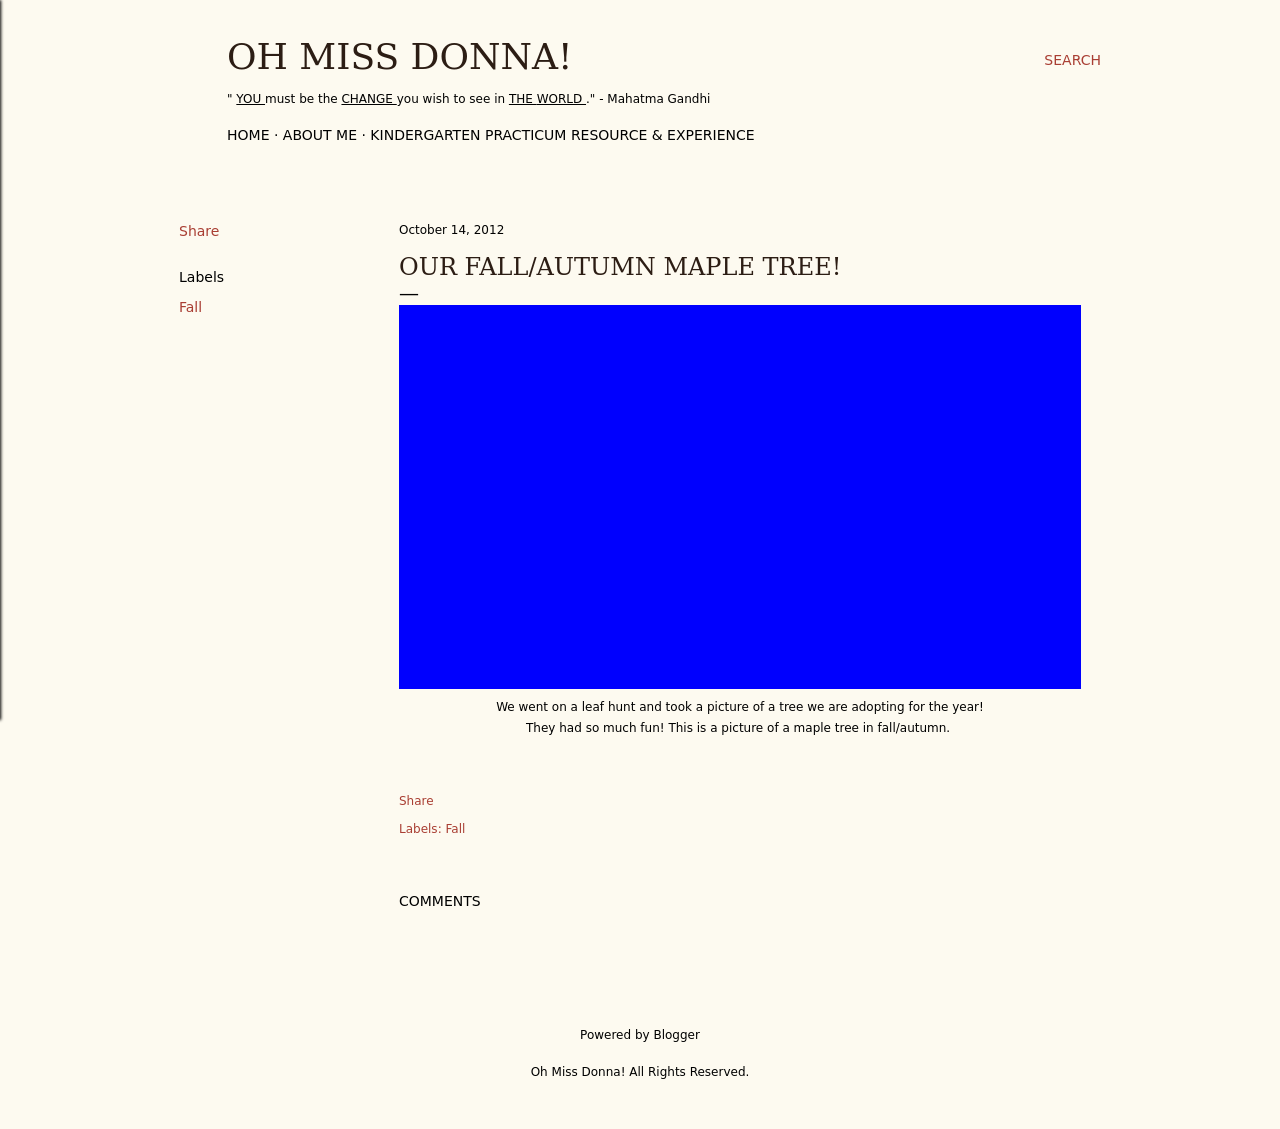Can you tell me more about the type of tree shown in this blog post? Certainly! The image features a maple tree, specifically noted in the blog post as one they're 'adopting for the year.' Maple trees are famous for their vibrant fall colors, particularly shades of red, orange, and yellow. These trees are often quintessential symbols of autumn.  What activities can children engage in to learn about maple trees? Children can participate in a variety of educational activities to learn about maple trees. These can include leaf collection and identification, measuring tree growth over different seasons, and arts and crafts that use maple leaves. Additionally, they could engage in a storytelling session about the role of trees in the ecosystem or explore the process of photosynthesis in a simplified manner suitable for their age. 